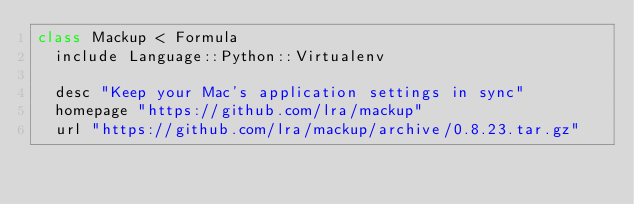<code> <loc_0><loc_0><loc_500><loc_500><_Ruby_>class Mackup < Formula
  include Language::Python::Virtualenv

  desc "Keep your Mac's application settings in sync"
  homepage "https://github.com/lra/mackup"
  url "https://github.com/lra/mackup/archive/0.8.23.tar.gz"</code> 